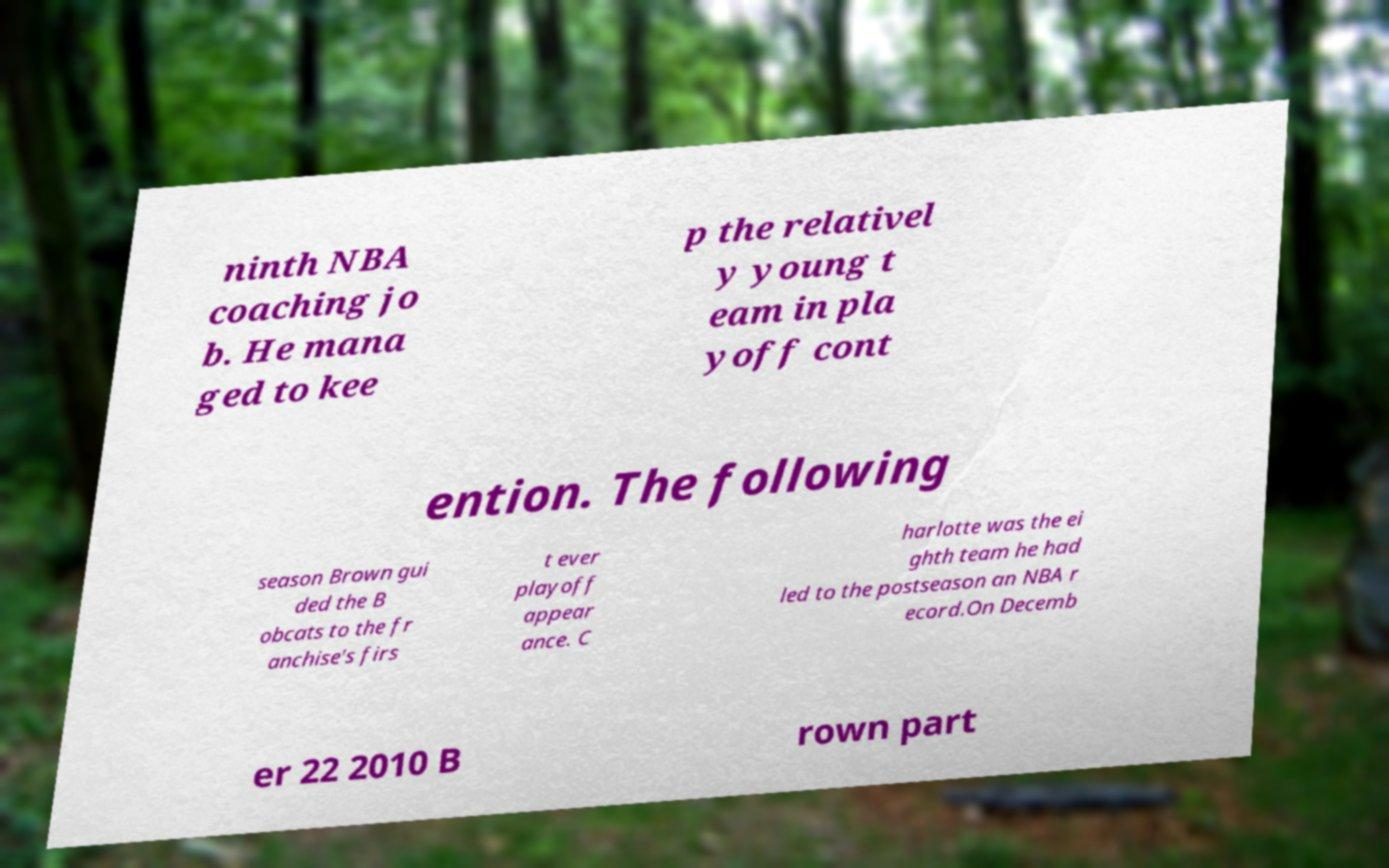I need the written content from this picture converted into text. Can you do that? ninth NBA coaching jo b. He mana ged to kee p the relativel y young t eam in pla yoff cont ention. The following season Brown gui ded the B obcats to the fr anchise's firs t ever playoff appear ance. C harlotte was the ei ghth team he had led to the postseason an NBA r ecord.On Decemb er 22 2010 B rown part 